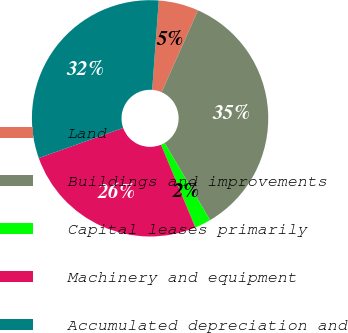<chart> <loc_0><loc_0><loc_500><loc_500><pie_chart><fcel>Land<fcel>Buildings and improvements<fcel>Capital leases primarily<fcel>Machinery and equipment<fcel>Accumulated depreciation and<nl><fcel>5.47%<fcel>34.88%<fcel>2.22%<fcel>25.8%<fcel>31.63%<nl></chart> 